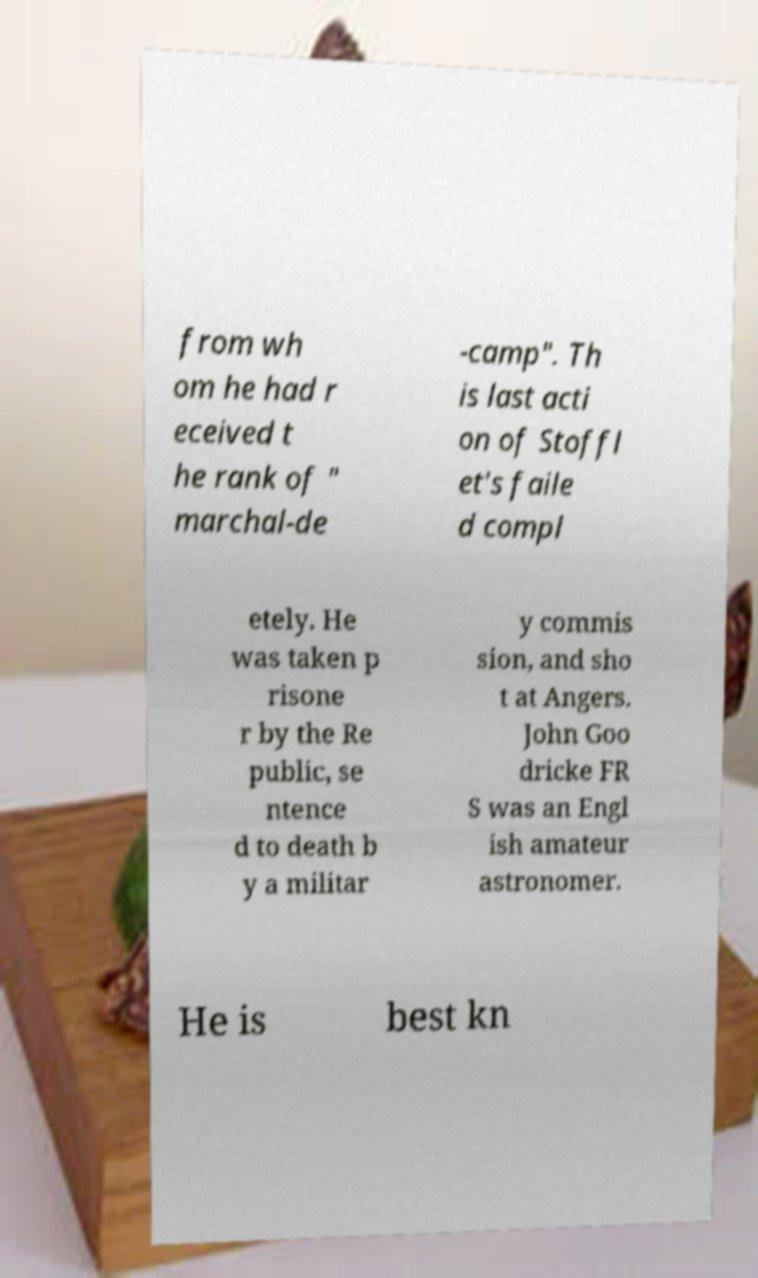Can you read and provide the text displayed in the image?This photo seems to have some interesting text. Can you extract and type it out for me? from wh om he had r eceived t he rank of " marchal-de -camp". Th is last acti on of Stoffl et's faile d compl etely. He was taken p risone r by the Re public, se ntence d to death b y a militar y commis sion, and sho t at Angers. John Goo dricke FR S was an Engl ish amateur astronomer. He is best kn 